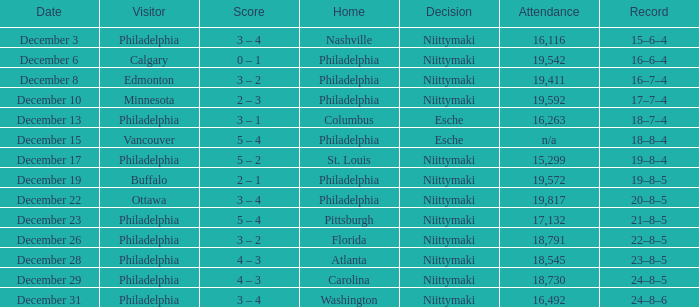What was the resolution made with 19,592 attendees present? Niittymaki. 